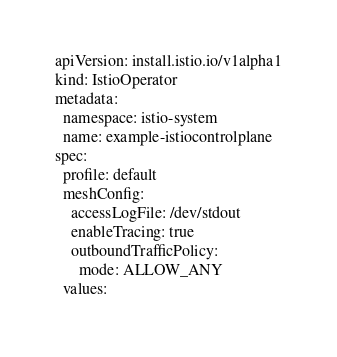Convert code to text. <code><loc_0><loc_0><loc_500><loc_500><_YAML_>apiVersion: install.istio.io/v1alpha1
kind: IstioOperator
metadata:
  namespace: istio-system
  name: example-istiocontrolplane
spec:
  profile: default
  meshConfig:
    accessLogFile: /dev/stdout
    enableTracing: true
    outboundTrafficPolicy:
      mode: ALLOW_ANY
  values:</code> 